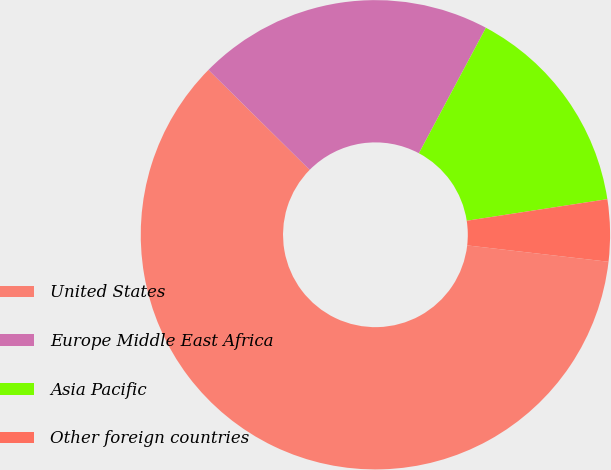Convert chart. <chart><loc_0><loc_0><loc_500><loc_500><pie_chart><fcel>United States<fcel>Europe Middle East Africa<fcel>Asia Pacific<fcel>Other foreign countries<nl><fcel>60.56%<fcel>20.4%<fcel>14.77%<fcel>4.26%<nl></chart> 